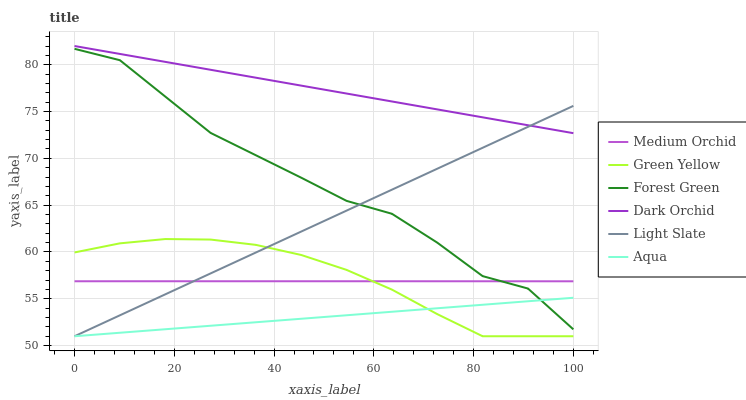Does Aqua have the minimum area under the curve?
Answer yes or no. Yes. Does Dark Orchid have the maximum area under the curve?
Answer yes or no. Yes. Does Medium Orchid have the minimum area under the curve?
Answer yes or no. No. Does Medium Orchid have the maximum area under the curve?
Answer yes or no. No. Is Dark Orchid the smoothest?
Answer yes or no. Yes. Is Forest Green the roughest?
Answer yes or no. Yes. Is Medium Orchid the smoothest?
Answer yes or no. No. Is Medium Orchid the roughest?
Answer yes or no. No. Does Light Slate have the lowest value?
Answer yes or no. Yes. Does Medium Orchid have the lowest value?
Answer yes or no. No. Does Dark Orchid have the highest value?
Answer yes or no. Yes. Does Medium Orchid have the highest value?
Answer yes or no. No. Is Forest Green less than Dark Orchid?
Answer yes or no. Yes. Is Medium Orchid greater than Aqua?
Answer yes or no. Yes. Does Medium Orchid intersect Forest Green?
Answer yes or no. Yes. Is Medium Orchid less than Forest Green?
Answer yes or no. No. Is Medium Orchid greater than Forest Green?
Answer yes or no. No. Does Forest Green intersect Dark Orchid?
Answer yes or no. No. 